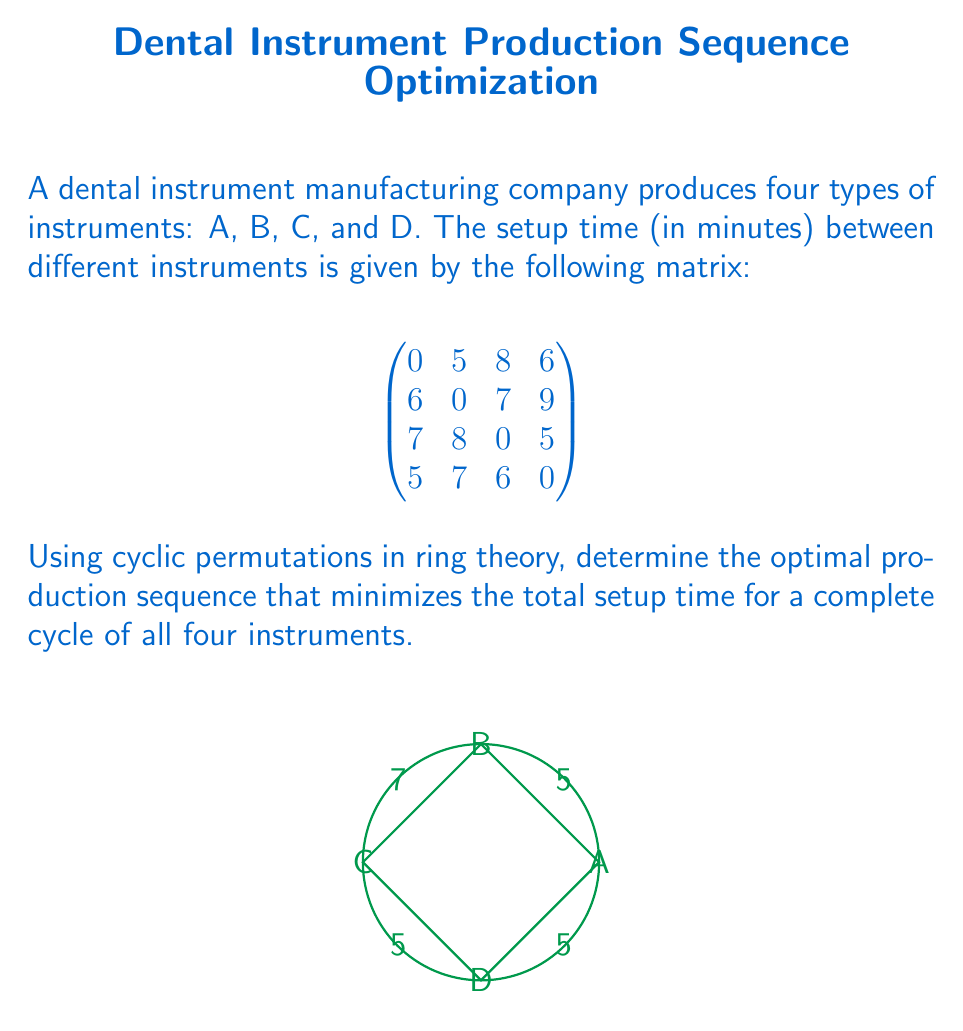Can you answer this question? To solve this problem, we'll use cyclic permutations in ring theory to find the optimal production sequence:

1) First, list all possible cyclic permutations:
   (A,B,C,D), (A,B,D,C), (A,C,B,D), (A,C,D,B), (A,D,B,C), (A,D,C,B)

2) Calculate the total setup time for each permutation:

   (A,B,C,D): 5 + 7 + 5 + 5 = 22
   (A,B,D,C): 5 + 9 + 6 + 7 = 27
   (A,C,B,D): 8 + 8 + 9 + 5 = 30
   (A,C,D,B): 8 + 5 + 7 + 6 = 26
   (A,D,B,C): 6 + 6 + 7 + 7 = 26
   (A,D,C,B): 6 + 6 + 8 + 6 = 26

3) The minimum setup time is 22, corresponding to the sequence (A,B,C,D).

4) In ring theory, this cyclic permutation can be represented as:

   $$\sigma = \begin{pmatrix} A & B & C & D \\ B & C & D & A \end{pmatrix}$$

5) This permutation generates the cyclic subgroup $\langle\sigma\rangle$ of order 4 in the symmetric group $S_4$.

Therefore, the optimal production sequence is (A,B,C,D), which completes one cycle of the ring with minimal setup time.
Answer: (A,B,C,D) 